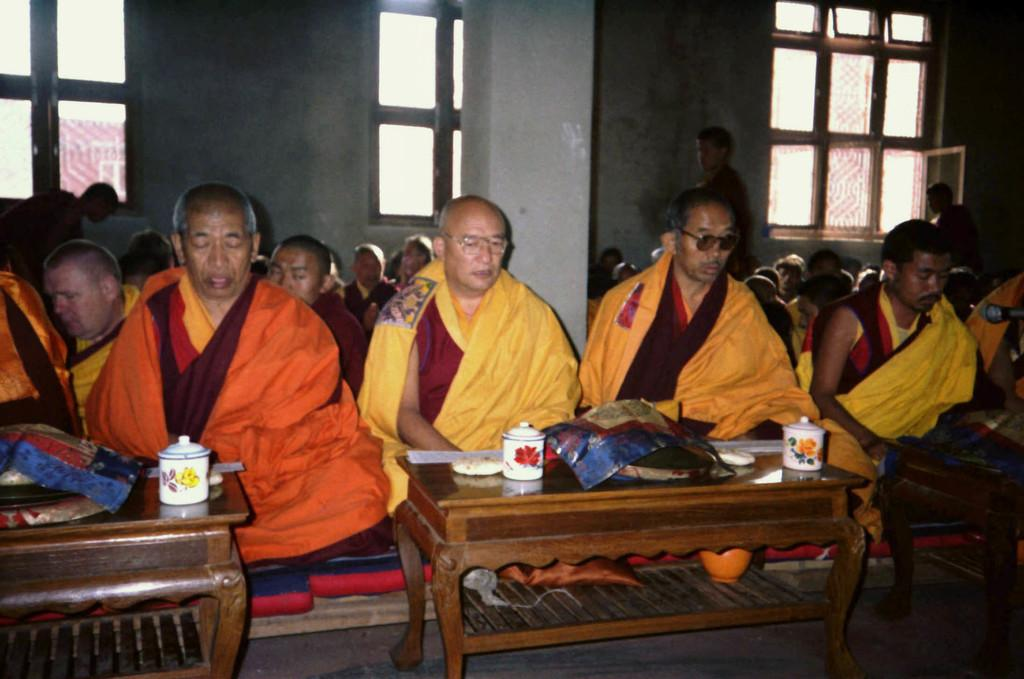What architectural feature can be seen in the image? There is a window and a wall in the image. What are the people in the image doing? The people are sitting on the floor in the image. How many tables are visible in the image? There are two tables in the image. What type of fruit can be smelled in the image? There is no fruit present in the image, so it cannot be smelled or identified. 